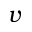<formula> <loc_0><loc_0><loc_500><loc_500>v</formula> 